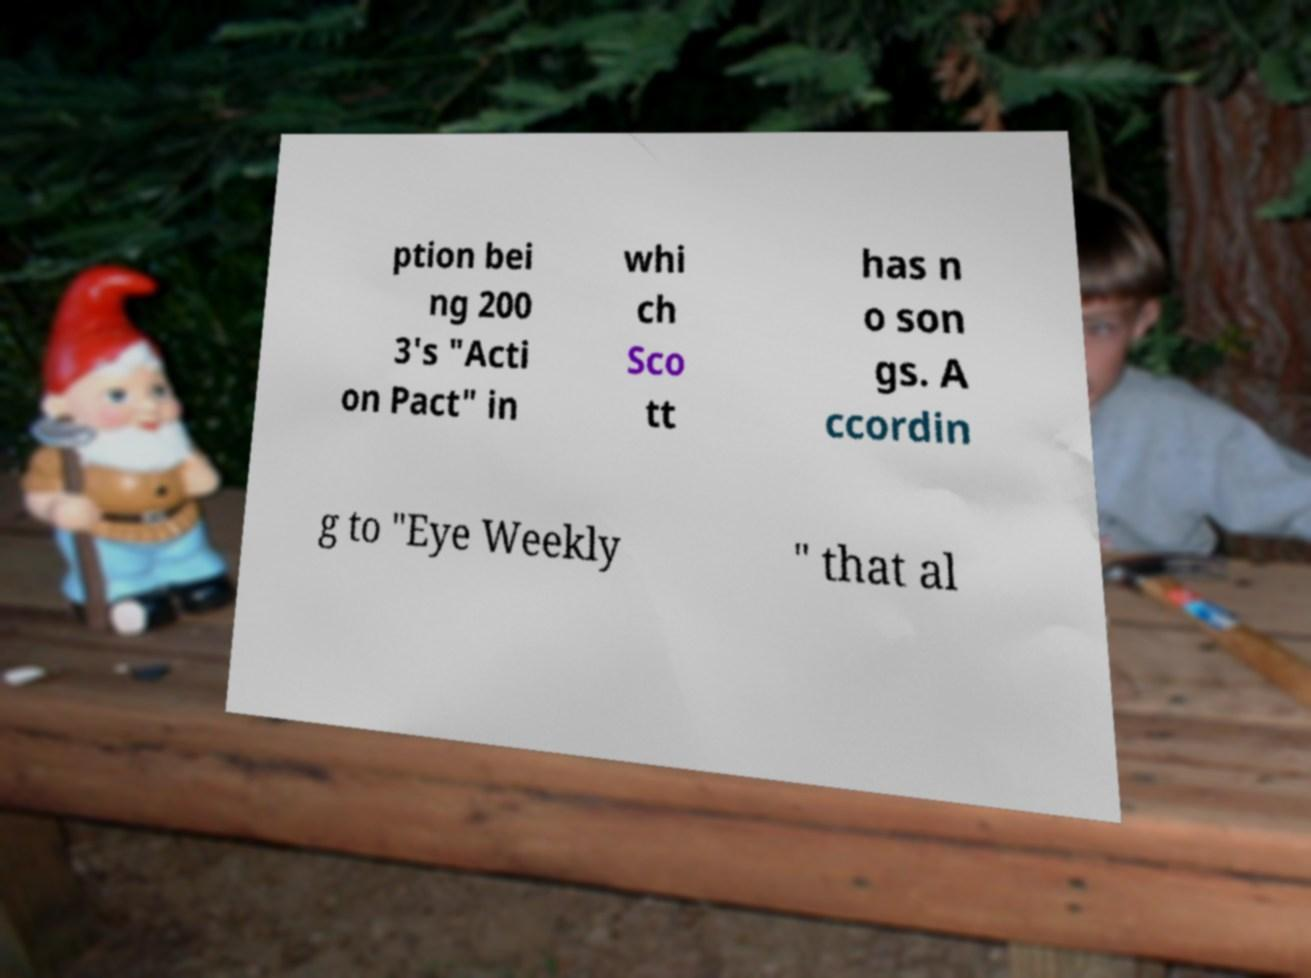For documentation purposes, I need the text within this image transcribed. Could you provide that? ption bei ng 200 3's "Acti on Pact" in whi ch Sco tt has n o son gs. A ccordin g to "Eye Weekly " that al 